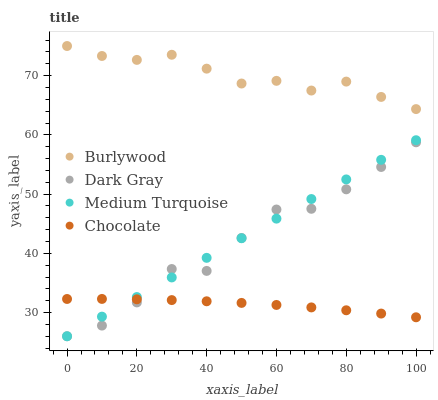Does Chocolate have the minimum area under the curve?
Answer yes or no. Yes. Does Burlywood have the maximum area under the curve?
Answer yes or no. Yes. Does Dark Gray have the minimum area under the curve?
Answer yes or no. No. Does Dark Gray have the maximum area under the curve?
Answer yes or no. No. Is Medium Turquoise the smoothest?
Answer yes or no. Yes. Is Dark Gray the roughest?
Answer yes or no. Yes. Is Dark Gray the smoothest?
Answer yes or no. No. Is Medium Turquoise the roughest?
Answer yes or no. No. Does Dark Gray have the lowest value?
Answer yes or no. Yes. Does Chocolate have the lowest value?
Answer yes or no. No. Does Burlywood have the highest value?
Answer yes or no. Yes. Does Dark Gray have the highest value?
Answer yes or no. No. Is Chocolate less than Burlywood?
Answer yes or no. Yes. Is Burlywood greater than Medium Turquoise?
Answer yes or no. Yes. Does Chocolate intersect Dark Gray?
Answer yes or no. Yes. Is Chocolate less than Dark Gray?
Answer yes or no. No. Is Chocolate greater than Dark Gray?
Answer yes or no. No. Does Chocolate intersect Burlywood?
Answer yes or no. No. 